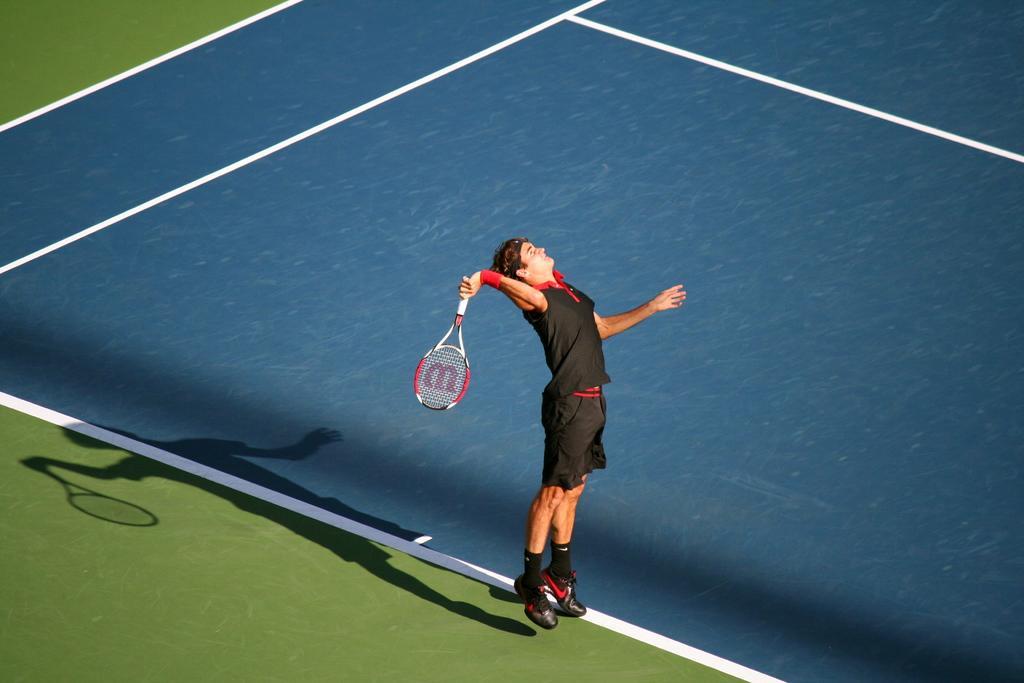In one or two sentences, can you explain what this image depicts? In this image there is a person jumping on the playground and he is holding a tennis racket. 